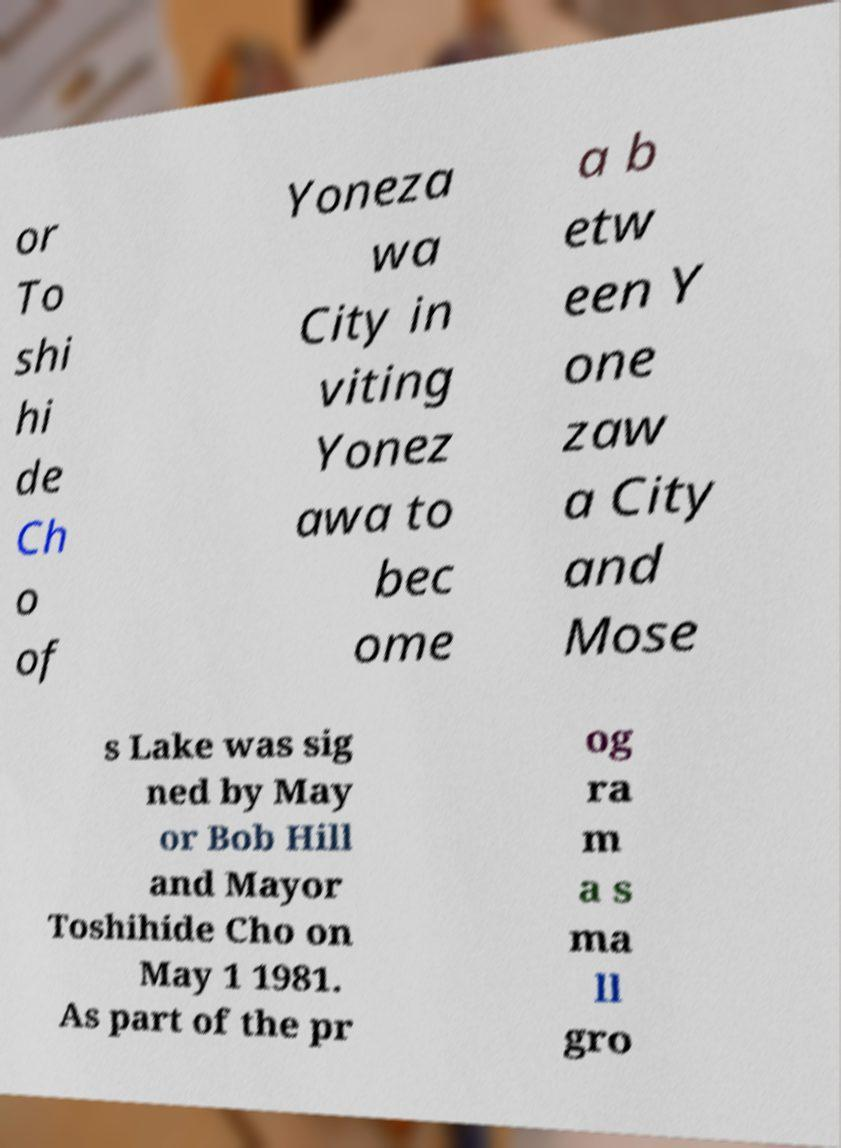I need the written content from this picture converted into text. Can you do that? or To shi hi de Ch o of Yoneza wa City in viting Yonez awa to bec ome a b etw een Y one zaw a City and Mose s Lake was sig ned by May or Bob Hill and Mayor Toshihide Cho on May 1 1981. As part of the pr og ra m a s ma ll gro 